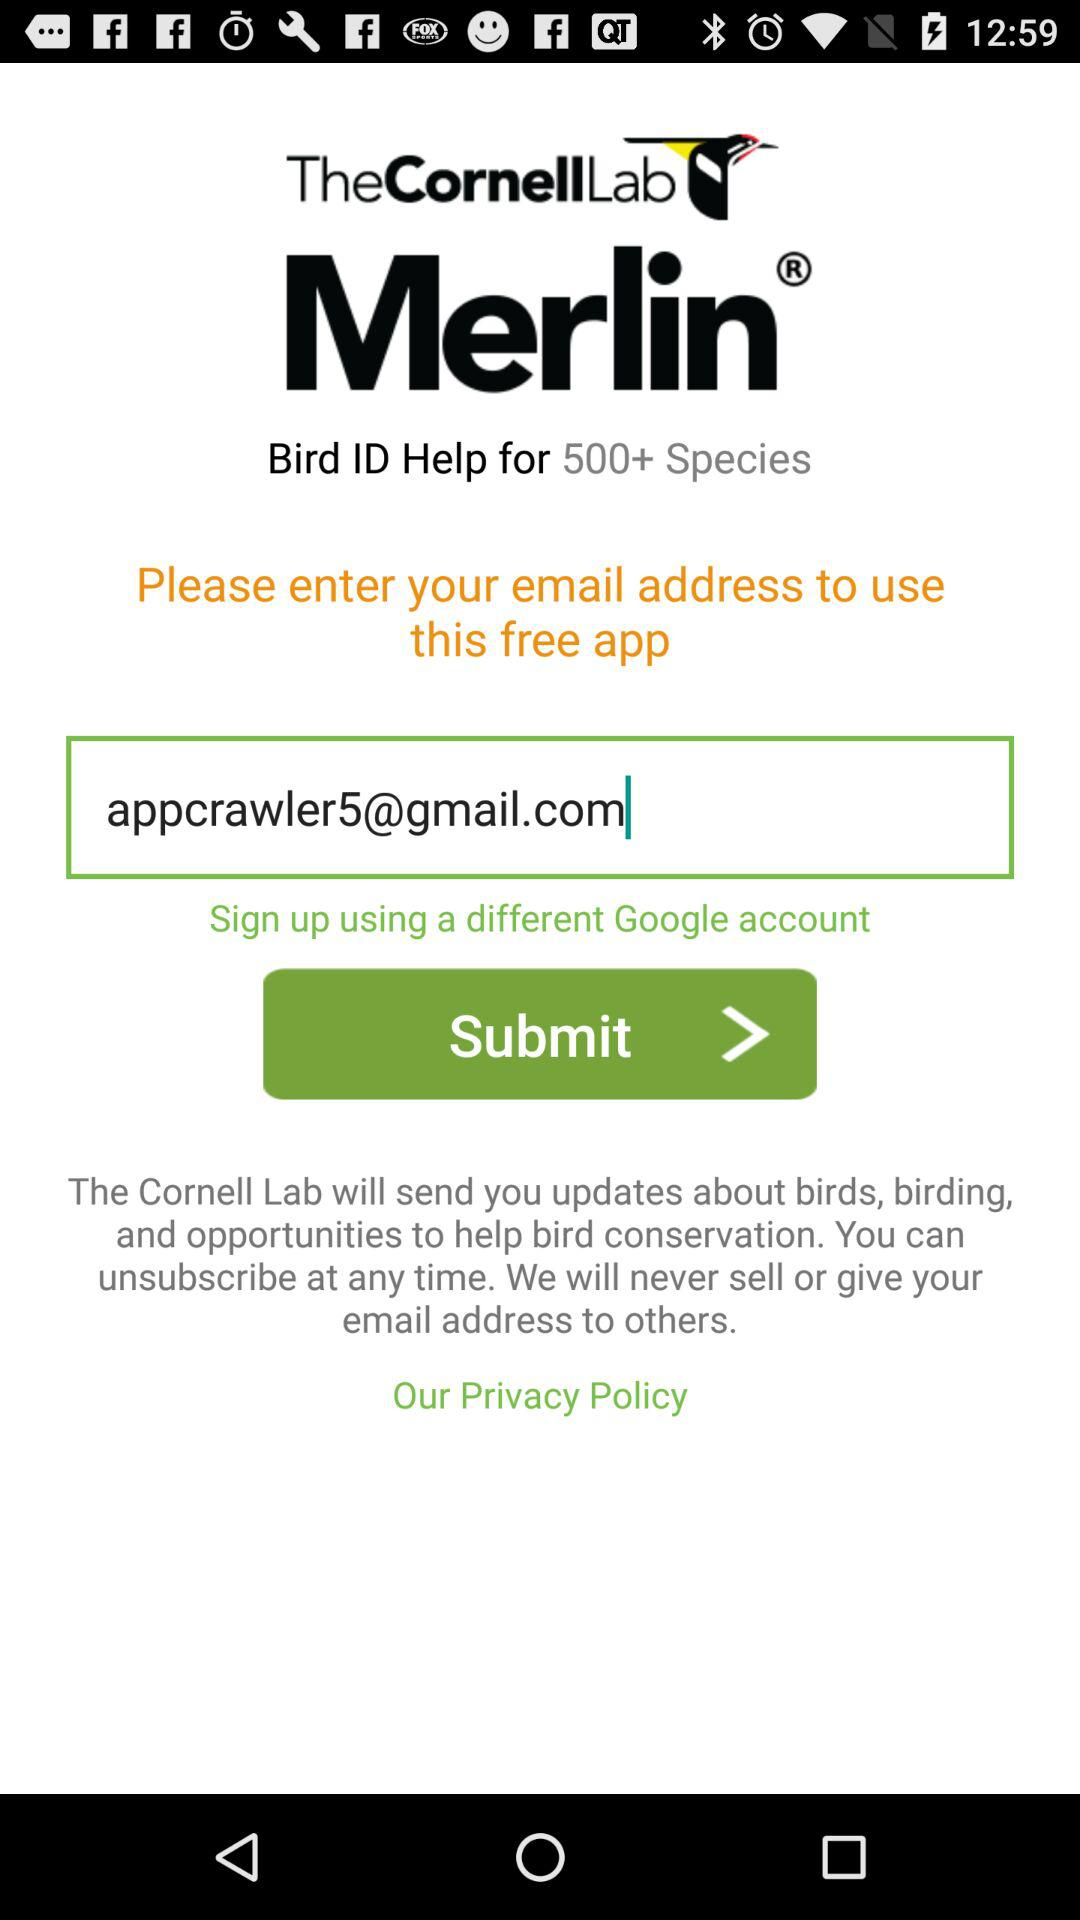Is the app free or paid? The app is free. 